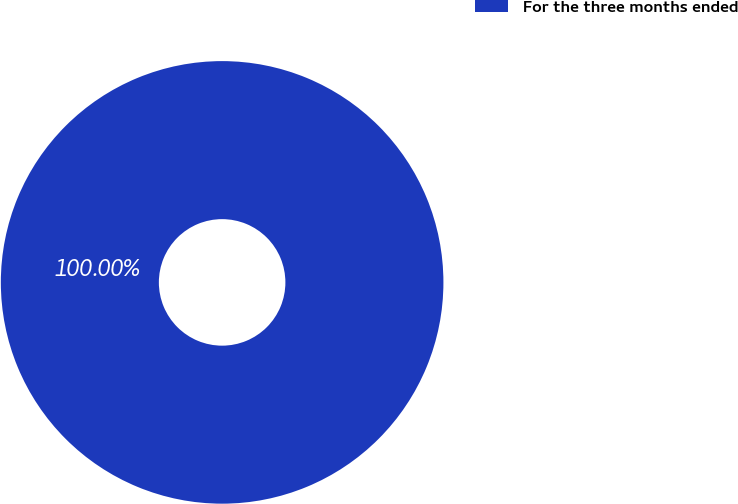Convert chart to OTSL. <chart><loc_0><loc_0><loc_500><loc_500><pie_chart><fcel>For the three months ended<nl><fcel>100.0%<nl></chart> 